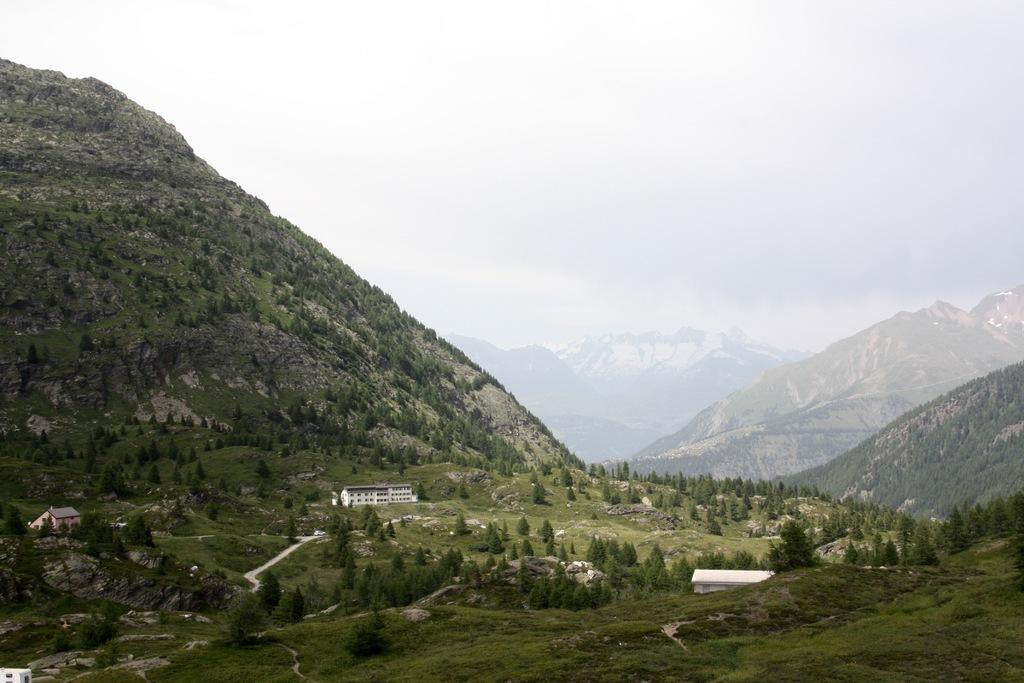What type of structures can be seen in the image? There are buildings in the image. What other natural elements are present in the image? There are trees and mountains in the image. What can be seen in the background of the image? The sky is visible in the background of the image. What is the condition of the sky in the image? Clouds are present in the sky. What type of cup can be seen in the hands of the rat in the image? There is no rat or cup present in the image. 